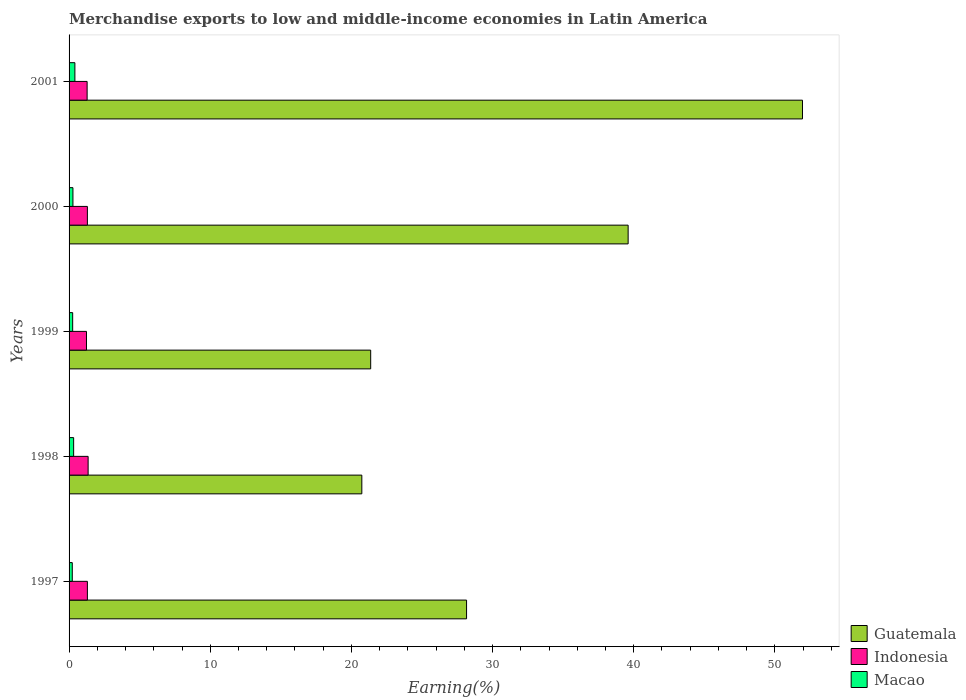How many different coloured bars are there?
Give a very brief answer. 3. How many groups of bars are there?
Provide a short and direct response. 5. Are the number of bars per tick equal to the number of legend labels?
Your response must be concise. Yes. Are the number of bars on each tick of the Y-axis equal?
Offer a terse response. Yes. How many bars are there on the 3rd tick from the top?
Keep it short and to the point. 3. What is the label of the 2nd group of bars from the top?
Keep it short and to the point. 2000. In how many cases, is the number of bars for a given year not equal to the number of legend labels?
Your answer should be very brief. 0. What is the percentage of amount earned from merchandise exports in Indonesia in 2001?
Ensure brevity in your answer.  1.28. Across all years, what is the maximum percentage of amount earned from merchandise exports in Macao?
Your answer should be very brief. 0.41. Across all years, what is the minimum percentage of amount earned from merchandise exports in Macao?
Make the answer very short. 0.23. In which year was the percentage of amount earned from merchandise exports in Macao maximum?
Give a very brief answer. 2001. In which year was the percentage of amount earned from merchandise exports in Macao minimum?
Make the answer very short. 1997. What is the total percentage of amount earned from merchandise exports in Indonesia in the graph?
Make the answer very short. 6.46. What is the difference between the percentage of amount earned from merchandise exports in Macao in 1997 and that in 1999?
Your answer should be very brief. -0.03. What is the difference between the percentage of amount earned from merchandise exports in Guatemala in 2000 and the percentage of amount earned from merchandise exports in Indonesia in 1999?
Give a very brief answer. 38.37. What is the average percentage of amount earned from merchandise exports in Indonesia per year?
Provide a succinct answer. 1.29. In the year 2001, what is the difference between the percentage of amount earned from merchandise exports in Guatemala and percentage of amount earned from merchandise exports in Macao?
Your answer should be compact. 51.54. In how many years, is the percentage of amount earned from merchandise exports in Macao greater than 22 %?
Make the answer very short. 0. What is the ratio of the percentage of amount earned from merchandise exports in Guatemala in 1997 to that in 2000?
Ensure brevity in your answer.  0.71. What is the difference between the highest and the second highest percentage of amount earned from merchandise exports in Macao?
Your response must be concise. 0.09. What is the difference between the highest and the lowest percentage of amount earned from merchandise exports in Macao?
Offer a very short reply. 0.19. What does the 1st bar from the top in 2001 represents?
Offer a very short reply. Macao. What does the 3rd bar from the bottom in 1997 represents?
Keep it short and to the point. Macao. Are all the bars in the graph horizontal?
Provide a succinct answer. Yes. Does the graph contain any zero values?
Offer a very short reply. No. Where does the legend appear in the graph?
Make the answer very short. Bottom right. How many legend labels are there?
Your answer should be compact. 3. How are the legend labels stacked?
Make the answer very short. Vertical. What is the title of the graph?
Offer a very short reply. Merchandise exports to low and middle-income economies in Latin America. Does "Hungary" appear as one of the legend labels in the graph?
Give a very brief answer. No. What is the label or title of the X-axis?
Keep it short and to the point. Earning(%). What is the Earning(%) in Guatemala in 1997?
Keep it short and to the point. 28.16. What is the Earning(%) in Indonesia in 1997?
Ensure brevity in your answer.  1.3. What is the Earning(%) of Macao in 1997?
Give a very brief answer. 0.23. What is the Earning(%) in Guatemala in 1998?
Provide a succinct answer. 20.74. What is the Earning(%) in Indonesia in 1998?
Your answer should be very brief. 1.35. What is the Earning(%) of Macao in 1998?
Your response must be concise. 0.32. What is the Earning(%) of Guatemala in 1999?
Your answer should be very brief. 21.37. What is the Earning(%) of Indonesia in 1999?
Give a very brief answer. 1.23. What is the Earning(%) of Macao in 1999?
Offer a terse response. 0.25. What is the Earning(%) of Guatemala in 2000?
Provide a short and direct response. 39.61. What is the Earning(%) in Indonesia in 2000?
Offer a very short reply. 1.3. What is the Earning(%) of Macao in 2000?
Offer a very short reply. 0.27. What is the Earning(%) of Guatemala in 2001?
Your response must be concise. 51.96. What is the Earning(%) in Indonesia in 2001?
Ensure brevity in your answer.  1.28. What is the Earning(%) in Macao in 2001?
Provide a succinct answer. 0.41. Across all years, what is the maximum Earning(%) in Guatemala?
Offer a very short reply. 51.96. Across all years, what is the maximum Earning(%) in Indonesia?
Provide a short and direct response. 1.35. Across all years, what is the maximum Earning(%) in Macao?
Keep it short and to the point. 0.41. Across all years, what is the minimum Earning(%) of Guatemala?
Offer a terse response. 20.74. Across all years, what is the minimum Earning(%) in Indonesia?
Keep it short and to the point. 1.23. Across all years, what is the minimum Earning(%) of Macao?
Offer a terse response. 0.23. What is the total Earning(%) of Guatemala in the graph?
Offer a terse response. 161.83. What is the total Earning(%) of Indonesia in the graph?
Offer a terse response. 6.46. What is the total Earning(%) in Macao in the graph?
Provide a short and direct response. 1.49. What is the difference between the Earning(%) in Guatemala in 1997 and that in 1998?
Offer a terse response. 7.42. What is the difference between the Earning(%) of Indonesia in 1997 and that in 1998?
Your response must be concise. -0.05. What is the difference between the Earning(%) in Macao in 1997 and that in 1998?
Provide a succinct answer. -0.1. What is the difference between the Earning(%) of Guatemala in 1997 and that in 1999?
Your response must be concise. 6.79. What is the difference between the Earning(%) in Indonesia in 1997 and that in 1999?
Provide a succinct answer. 0.06. What is the difference between the Earning(%) of Macao in 1997 and that in 1999?
Ensure brevity in your answer.  -0.03. What is the difference between the Earning(%) in Guatemala in 1997 and that in 2000?
Offer a very short reply. -11.45. What is the difference between the Earning(%) in Indonesia in 1997 and that in 2000?
Provide a succinct answer. -0. What is the difference between the Earning(%) of Macao in 1997 and that in 2000?
Your answer should be compact. -0.05. What is the difference between the Earning(%) of Guatemala in 1997 and that in 2001?
Your answer should be very brief. -23.8. What is the difference between the Earning(%) of Indonesia in 1997 and that in 2001?
Make the answer very short. 0.02. What is the difference between the Earning(%) in Macao in 1997 and that in 2001?
Offer a very short reply. -0.19. What is the difference between the Earning(%) in Guatemala in 1998 and that in 1999?
Offer a terse response. -0.63. What is the difference between the Earning(%) of Indonesia in 1998 and that in 1999?
Offer a terse response. 0.12. What is the difference between the Earning(%) of Macao in 1998 and that in 1999?
Offer a terse response. 0.07. What is the difference between the Earning(%) in Guatemala in 1998 and that in 2000?
Your answer should be compact. -18.87. What is the difference between the Earning(%) of Indonesia in 1998 and that in 2000?
Your answer should be very brief. 0.05. What is the difference between the Earning(%) in Macao in 1998 and that in 2000?
Provide a short and direct response. 0.05. What is the difference between the Earning(%) of Guatemala in 1998 and that in 2001?
Provide a short and direct response. -31.22. What is the difference between the Earning(%) in Indonesia in 1998 and that in 2001?
Offer a terse response. 0.07. What is the difference between the Earning(%) of Macao in 1998 and that in 2001?
Provide a short and direct response. -0.09. What is the difference between the Earning(%) of Guatemala in 1999 and that in 2000?
Give a very brief answer. -18.24. What is the difference between the Earning(%) in Indonesia in 1999 and that in 2000?
Provide a succinct answer. -0.06. What is the difference between the Earning(%) of Macao in 1999 and that in 2000?
Provide a succinct answer. -0.02. What is the difference between the Earning(%) in Guatemala in 1999 and that in 2001?
Your answer should be very brief. -30.59. What is the difference between the Earning(%) in Indonesia in 1999 and that in 2001?
Offer a terse response. -0.04. What is the difference between the Earning(%) in Macao in 1999 and that in 2001?
Make the answer very short. -0.16. What is the difference between the Earning(%) of Guatemala in 2000 and that in 2001?
Offer a terse response. -12.35. What is the difference between the Earning(%) of Indonesia in 2000 and that in 2001?
Make the answer very short. 0.02. What is the difference between the Earning(%) in Macao in 2000 and that in 2001?
Provide a short and direct response. -0.14. What is the difference between the Earning(%) of Guatemala in 1997 and the Earning(%) of Indonesia in 1998?
Ensure brevity in your answer.  26.81. What is the difference between the Earning(%) in Guatemala in 1997 and the Earning(%) in Macao in 1998?
Provide a succinct answer. 27.84. What is the difference between the Earning(%) in Indonesia in 1997 and the Earning(%) in Macao in 1998?
Give a very brief answer. 0.97. What is the difference between the Earning(%) of Guatemala in 1997 and the Earning(%) of Indonesia in 1999?
Your answer should be compact. 26.93. What is the difference between the Earning(%) of Guatemala in 1997 and the Earning(%) of Macao in 1999?
Offer a terse response. 27.9. What is the difference between the Earning(%) in Indonesia in 1997 and the Earning(%) in Macao in 1999?
Your answer should be compact. 1.04. What is the difference between the Earning(%) of Guatemala in 1997 and the Earning(%) of Indonesia in 2000?
Your answer should be very brief. 26.86. What is the difference between the Earning(%) in Guatemala in 1997 and the Earning(%) in Macao in 2000?
Your answer should be very brief. 27.89. What is the difference between the Earning(%) of Indonesia in 1997 and the Earning(%) of Macao in 2000?
Make the answer very short. 1.02. What is the difference between the Earning(%) of Guatemala in 1997 and the Earning(%) of Indonesia in 2001?
Your answer should be compact. 26.88. What is the difference between the Earning(%) in Guatemala in 1997 and the Earning(%) in Macao in 2001?
Your answer should be compact. 27.75. What is the difference between the Earning(%) in Indonesia in 1997 and the Earning(%) in Macao in 2001?
Keep it short and to the point. 0.89. What is the difference between the Earning(%) in Guatemala in 1998 and the Earning(%) in Indonesia in 1999?
Provide a succinct answer. 19.51. What is the difference between the Earning(%) of Guatemala in 1998 and the Earning(%) of Macao in 1999?
Provide a succinct answer. 20.49. What is the difference between the Earning(%) of Indonesia in 1998 and the Earning(%) of Macao in 1999?
Your response must be concise. 1.09. What is the difference between the Earning(%) in Guatemala in 1998 and the Earning(%) in Indonesia in 2000?
Ensure brevity in your answer.  19.44. What is the difference between the Earning(%) in Guatemala in 1998 and the Earning(%) in Macao in 2000?
Ensure brevity in your answer.  20.47. What is the difference between the Earning(%) in Indonesia in 1998 and the Earning(%) in Macao in 2000?
Your answer should be compact. 1.08. What is the difference between the Earning(%) of Guatemala in 1998 and the Earning(%) of Indonesia in 2001?
Your answer should be compact. 19.46. What is the difference between the Earning(%) of Guatemala in 1998 and the Earning(%) of Macao in 2001?
Offer a very short reply. 20.33. What is the difference between the Earning(%) in Indonesia in 1998 and the Earning(%) in Macao in 2001?
Offer a terse response. 0.94. What is the difference between the Earning(%) in Guatemala in 1999 and the Earning(%) in Indonesia in 2000?
Offer a very short reply. 20.07. What is the difference between the Earning(%) in Guatemala in 1999 and the Earning(%) in Macao in 2000?
Make the answer very short. 21.09. What is the difference between the Earning(%) of Indonesia in 1999 and the Earning(%) of Macao in 2000?
Provide a succinct answer. 0.96. What is the difference between the Earning(%) in Guatemala in 1999 and the Earning(%) in Indonesia in 2001?
Make the answer very short. 20.09. What is the difference between the Earning(%) in Guatemala in 1999 and the Earning(%) in Macao in 2001?
Your answer should be very brief. 20.96. What is the difference between the Earning(%) of Indonesia in 1999 and the Earning(%) of Macao in 2001?
Offer a terse response. 0.82. What is the difference between the Earning(%) in Guatemala in 2000 and the Earning(%) in Indonesia in 2001?
Your answer should be very brief. 38.33. What is the difference between the Earning(%) in Guatemala in 2000 and the Earning(%) in Macao in 2001?
Your answer should be very brief. 39.19. What is the difference between the Earning(%) in Indonesia in 2000 and the Earning(%) in Macao in 2001?
Give a very brief answer. 0.89. What is the average Earning(%) in Guatemala per year?
Provide a succinct answer. 32.37. What is the average Earning(%) in Indonesia per year?
Offer a very short reply. 1.29. What is the average Earning(%) of Macao per year?
Ensure brevity in your answer.  0.3. In the year 1997, what is the difference between the Earning(%) in Guatemala and Earning(%) in Indonesia?
Offer a very short reply. 26.86. In the year 1997, what is the difference between the Earning(%) of Guatemala and Earning(%) of Macao?
Your answer should be compact. 27.93. In the year 1997, what is the difference between the Earning(%) of Indonesia and Earning(%) of Macao?
Your response must be concise. 1.07. In the year 1998, what is the difference between the Earning(%) of Guatemala and Earning(%) of Indonesia?
Your response must be concise. 19.39. In the year 1998, what is the difference between the Earning(%) in Guatemala and Earning(%) in Macao?
Offer a very short reply. 20.42. In the year 1998, what is the difference between the Earning(%) in Indonesia and Earning(%) in Macao?
Offer a very short reply. 1.03. In the year 1999, what is the difference between the Earning(%) of Guatemala and Earning(%) of Indonesia?
Your response must be concise. 20.13. In the year 1999, what is the difference between the Earning(%) of Guatemala and Earning(%) of Macao?
Offer a very short reply. 21.11. In the year 1999, what is the difference between the Earning(%) of Indonesia and Earning(%) of Macao?
Offer a very short reply. 0.98. In the year 2000, what is the difference between the Earning(%) of Guatemala and Earning(%) of Indonesia?
Your response must be concise. 38.31. In the year 2000, what is the difference between the Earning(%) in Guatemala and Earning(%) in Macao?
Provide a succinct answer. 39.33. In the year 2000, what is the difference between the Earning(%) of Indonesia and Earning(%) of Macao?
Ensure brevity in your answer.  1.02. In the year 2001, what is the difference between the Earning(%) of Guatemala and Earning(%) of Indonesia?
Make the answer very short. 50.68. In the year 2001, what is the difference between the Earning(%) in Guatemala and Earning(%) in Macao?
Keep it short and to the point. 51.54. In the year 2001, what is the difference between the Earning(%) in Indonesia and Earning(%) in Macao?
Make the answer very short. 0.87. What is the ratio of the Earning(%) in Guatemala in 1997 to that in 1998?
Provide a short and direct response. 1.36. What is the ratio of the Earning(%) of Indonesia in 1997 to that in 1998?
Your answer should be very brief. 0.96. What is the ratio of the Earning(%) of Macao in 1997 to that in 1998?
Keep it short and to the point. 0.7. What is the ratio of the Earning(%) of Guatemala in 1997 to that in 1999?
Provide a short and direct response. 1.32. What is the ratio of the Earning(%) in Indonesia in 1997 to that in 1999?
Provide a short and direct response. 1.05. What is the ratio of the Earning(%) of Macao in 1997 to that in 1999?
Provide a succinct answer. 0.89. What is the ratio of the Earning(%) of Guatemala in 1997 to that in 2000?
Your answer should be very brief. 0.71. What is the ratio of the Earning(%) in Indonesia in 1997 to that in 2000?
Make the answer very short. 1. What is the ratio of the Earning(%) in Macao in 1997 to that in 2000?
Ensure brevity in your answer.  0.83. What is the ratio of the Earning(%) of Guatemala in 1997 to that in 2001?
Offer a very short reply. 0.54. What is the ratio of the Earning(%) of Indonesia in 1997 to that in 2001?
Provide a succinct answer. 1.01. What is the ratio of the Earning(%) of Macao in 1997 to that in 2001?
Offer a terse response. 0.55. What is the ratio of the Earning(%) in Guatemala in 1998 to that in 1999?
Offer a terse response. 0.97. What is the ratio of the Earning(%) of Indonesia in 1998 to that in 1999?
Offer a very short reply. 1.09. What is the ratio of the Earning(%) in Macao in 1998 to that in 1999?
Offer a very short reply. 1.27. What is the ratio of the Earning(%) in Guatemala in 1998 to that in 2000?
Make the answer very short. 0.52. What is the ratio of the Earning(%) of Indonesia in 1998 to that in 2000?
Your response must be concise. 1.04. What is the ratio of the Earning(%) of Macao in 1998 to that in 2000?
Keep it short and to the point. 1.18. What is the ratio of the Earning(%) in Guatemala in 1998 to that in 2001?
Keep it short and to the point. 0.4. What is the ratio of the Earning(%) in Indonesia in 1998 to that in 2001?
Provide a short and direct response. 1.06. What is the ratio of the Earning(%) of Macao in 1998 to that in 2001?
Make the answer very short. 0.78. What is the ratio of the Earning(%) in Guatemala in 1999 to that in 2000?
Provide a short and direct response. 0.54. What is the ratio of the Earning(%) in Indonesia in 1999 to that in 2000?
Keep it short and to the point. 0.95. What is the ratio of the Earning(%) of Macao in 1999 to that in 2000?
Offer a terse response. 0.93. What is the ratio of the Earning(%) of Guatemala in 1999 to that in 2001?
Keep it short and to the point. 0.41. What is the ratio of the Earning(%) in Indonesia in 1999 to that in 2001?
Your response must be concise. 0.97. What is the ratio of the Earning(%) in Macao in 1999 to that in 2001?
Provide a short and direct response. 0.62. What is the ratio of the Earning(%) of Guatemala in 2000 to that in 2001?
Offer a very short reply. 0.76. What is the ratio of the Earning(%) of Indonesia in 2000 to that in 2001?
Provide a succinct answer. 1.02. What is the ratio of the Earning(%) in Macao in 2000 to that in 2001?
Your answer should be compact. 0.67. What is the difference between the highest and the second highest Earning(%) in Guatemala?
Your answer should be compact. 12.35. What is the difference between the highest and the second highest Earning(%) of Indonesia?
Your answer should be very brief. 0.05. What is the difference between the highest and the second highest Earning(%) of Macao?
Ensure brevity in your answer.  0.09. What is the difference between the highest and the lowest Earning(%) of Guatemala?
Keep it short and to the point. 31.22. What is the difference between the highest and the lowest Earning(%) of Indonesia?
Keep it short and to the point. 0.12. What is the difference between the highest and the lowest Earning(%) of Macao?
Offer a terse response. 0.19. 